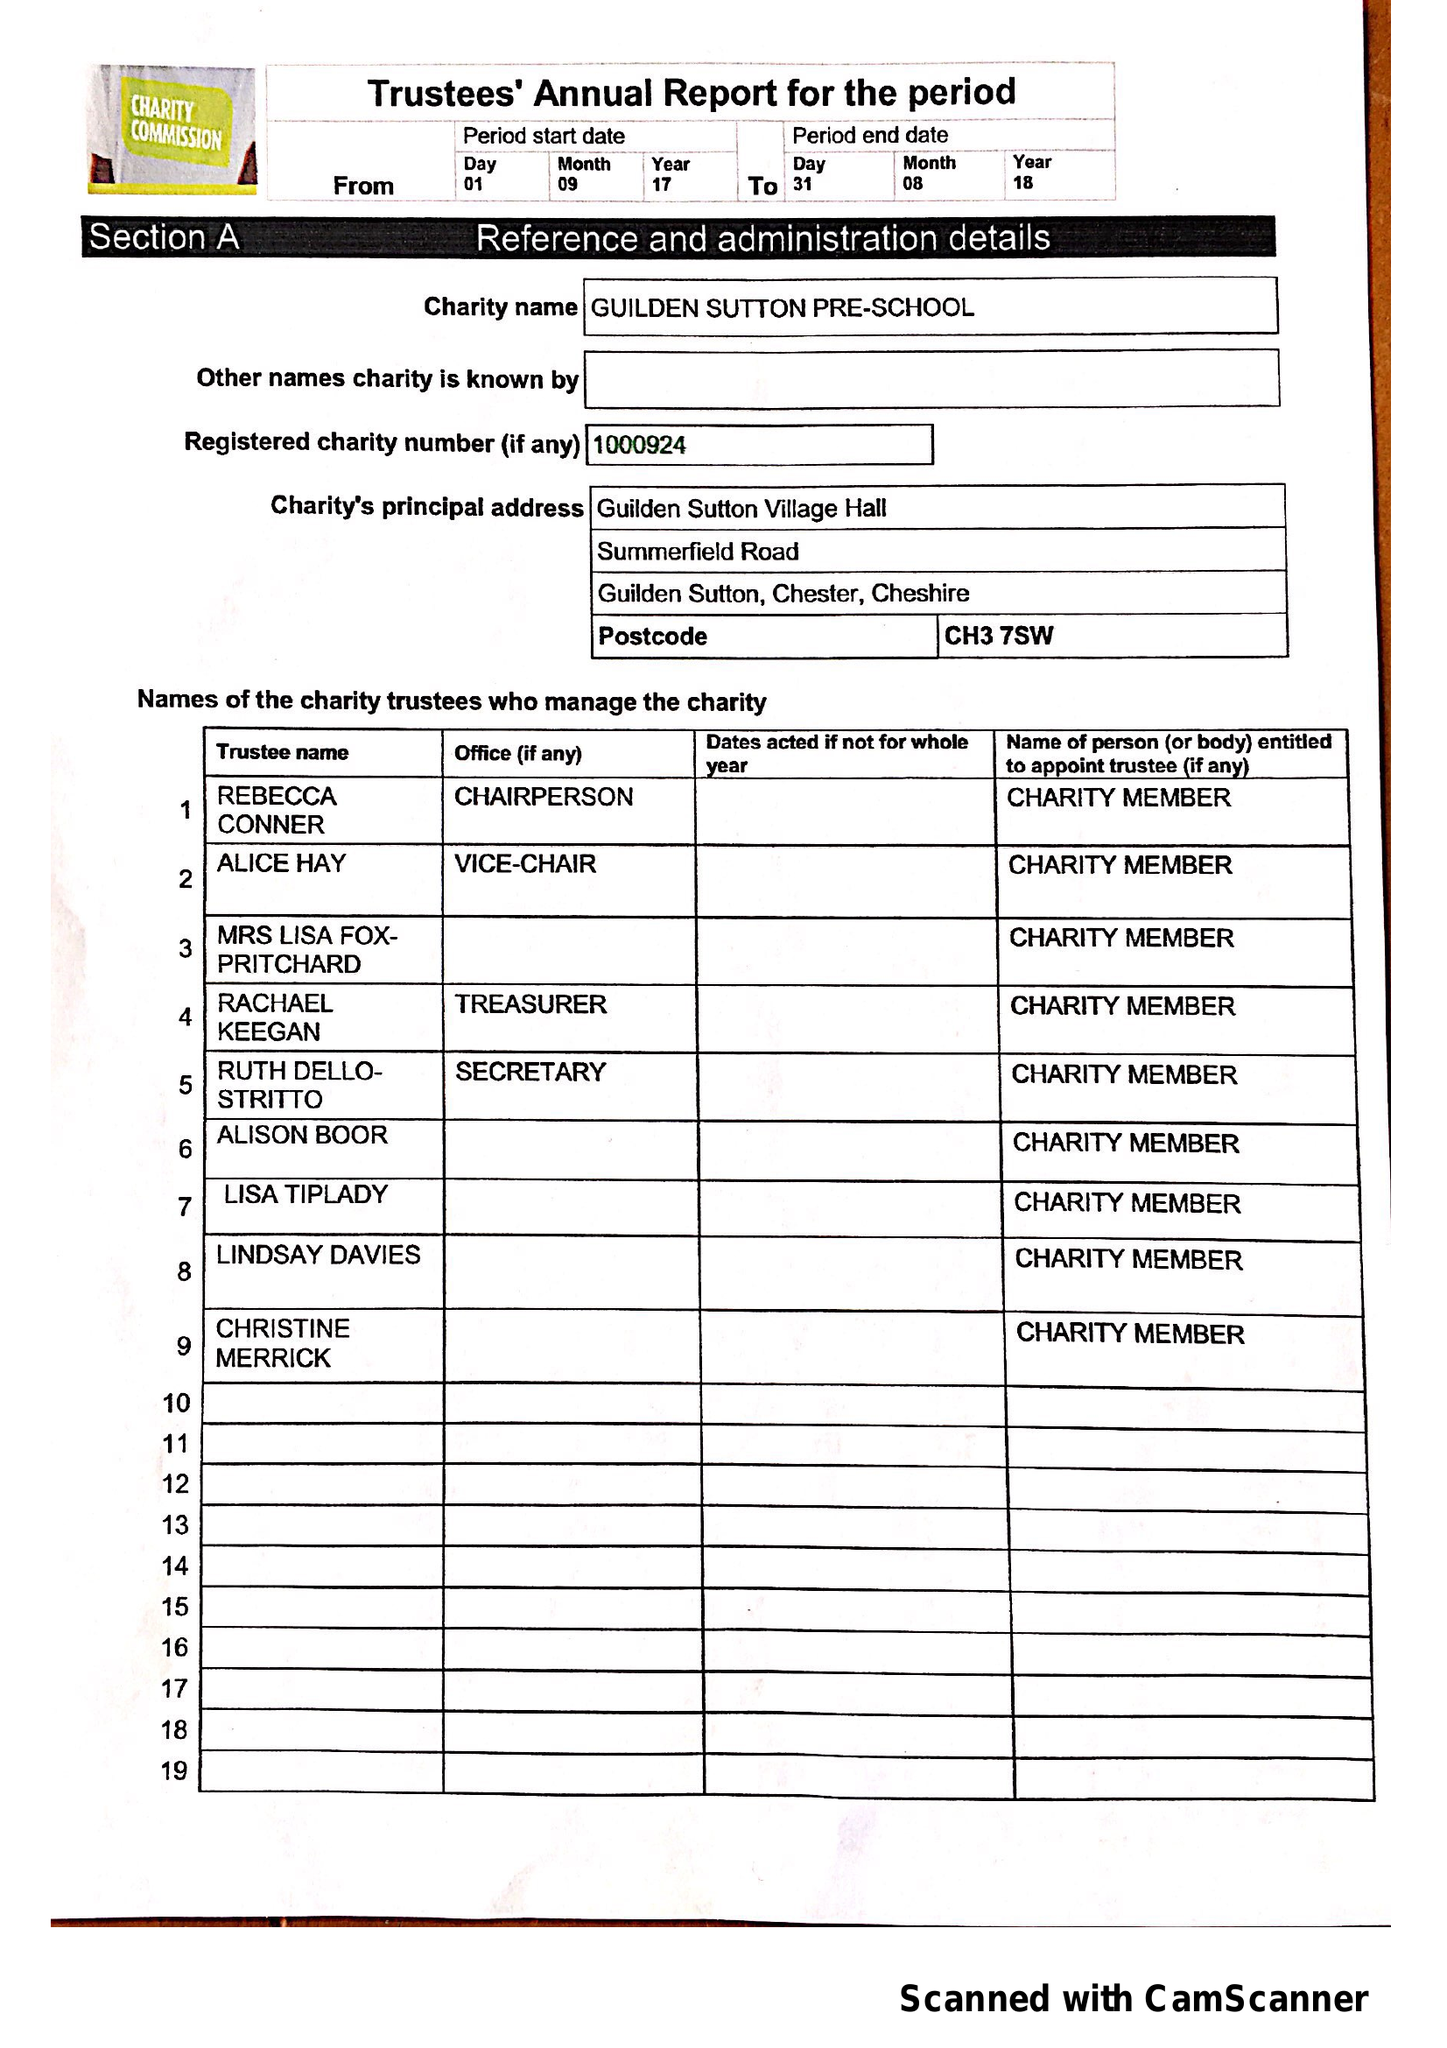What is the value for the spending_annually_in_british_pounds?
Answer the question using a single word or phrase. 29491.43 